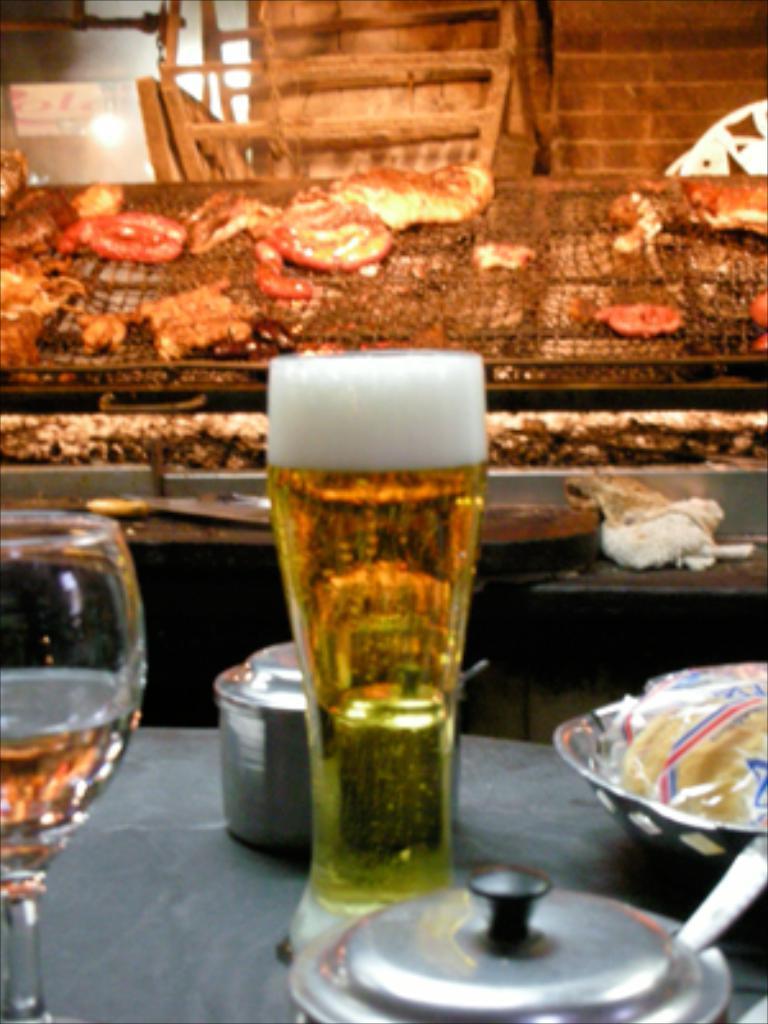In one or two sentences, can you explain what this image depicts? On this table there is a bowl, glasses with liquid, container and objects. 